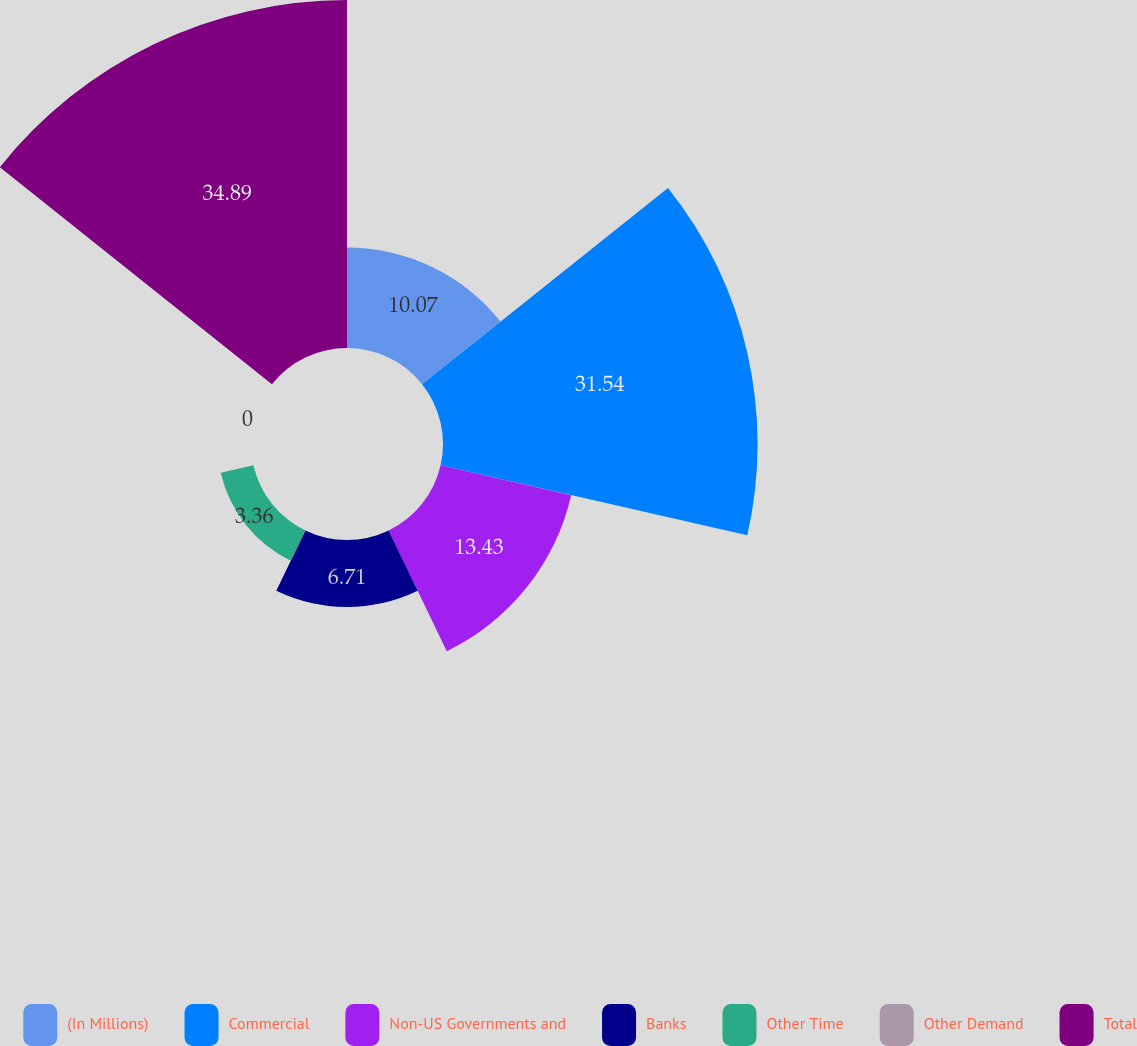Convert chart. <chart><loc_0><loc_0><loc_500><loc_500><pie_chart><fcel>(In Millions)<fcel>Commercial<fcel>Non-US Governments and<fcel>Banks<fcel>Other Time<fcel>Other Demand<fcel>Total<nl><fcel>10.07%<fcel>31.54%<fcel>13.43%<fcel>6.71%<fcel>3.36%<fcel>0.0%<fcel>34.89%<nl></chart> 